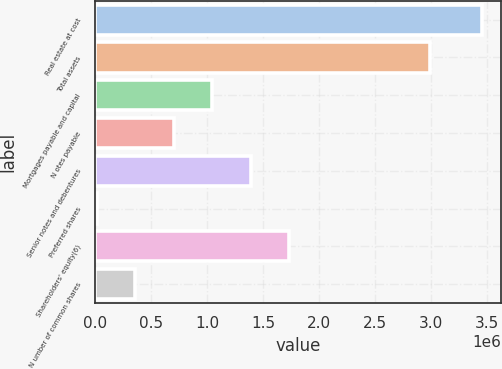Convert chart to OTSL. <chart><loc_0><loc_0><loc_500><loc_500><bar_chart><fcel>Real estate at cost<fcel>Total assets<fcel>Mortgages payable and capital<fcel>N otes payable<fcel>Senior notes and debentures<fcel>Preferred shares<fcel>Shareholders' equity(6)<fcel>N umber of common shares<nl><fcel>3.45285e+06<fcel>2.9893e+06<fcel>1.04285e+06<fcel>698567<fcel>1.38714e+06<fcel>9997<fcel>1.73142e+06<fcel>354282<nl></chart> 